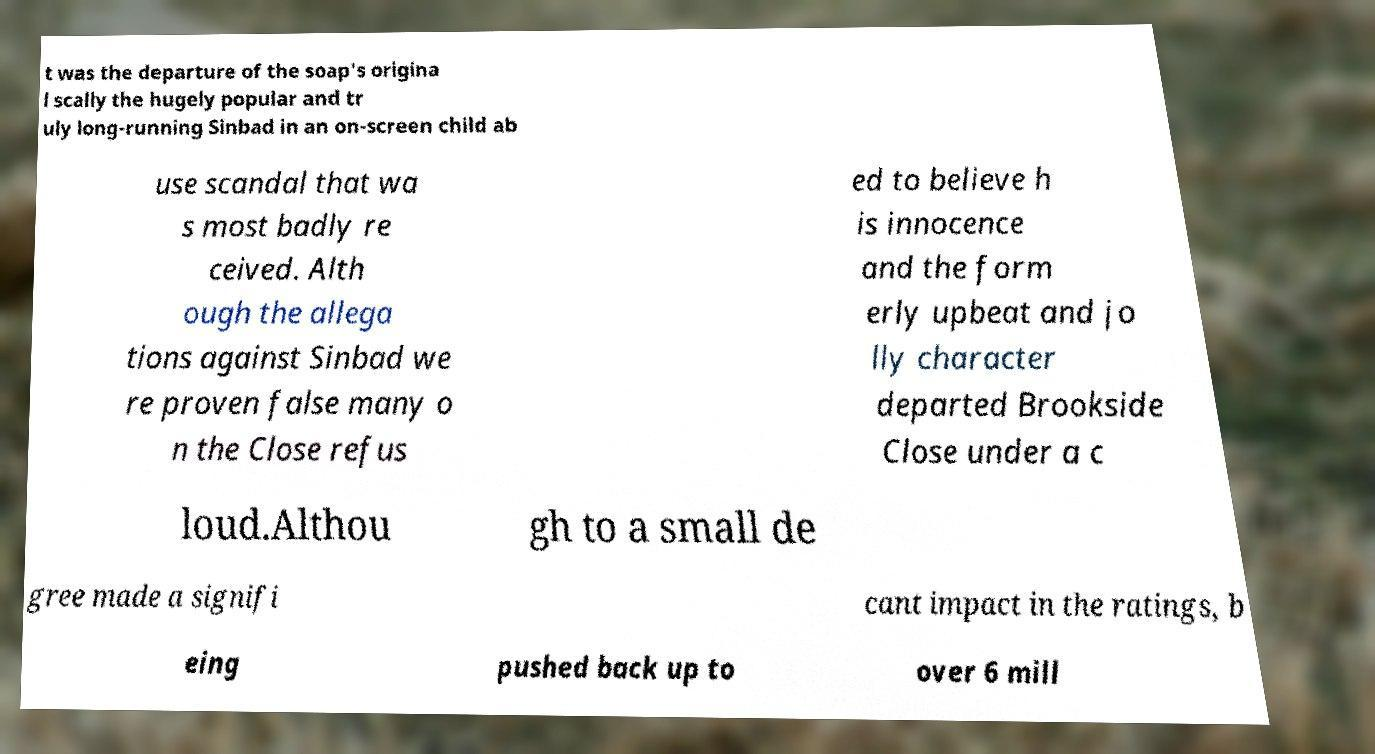Can you accurately transcribe the text from the provided image for me? t was the departure of the soap's origina l scally the hugely popular and tr uly long-running Sinbad in an on-screen child ab use scandal that wa s most badly re ceived. Alth ough the allega tions against Sinbad we re proven false many o n the Close refus ed to believe h is innocence and the form erly upbeat and jo lly character departed Brookside Close under a c loud.Althou gh to a small de gree made a signifi cant impact in the ratings, b eing pushed back up to over 6 mill 